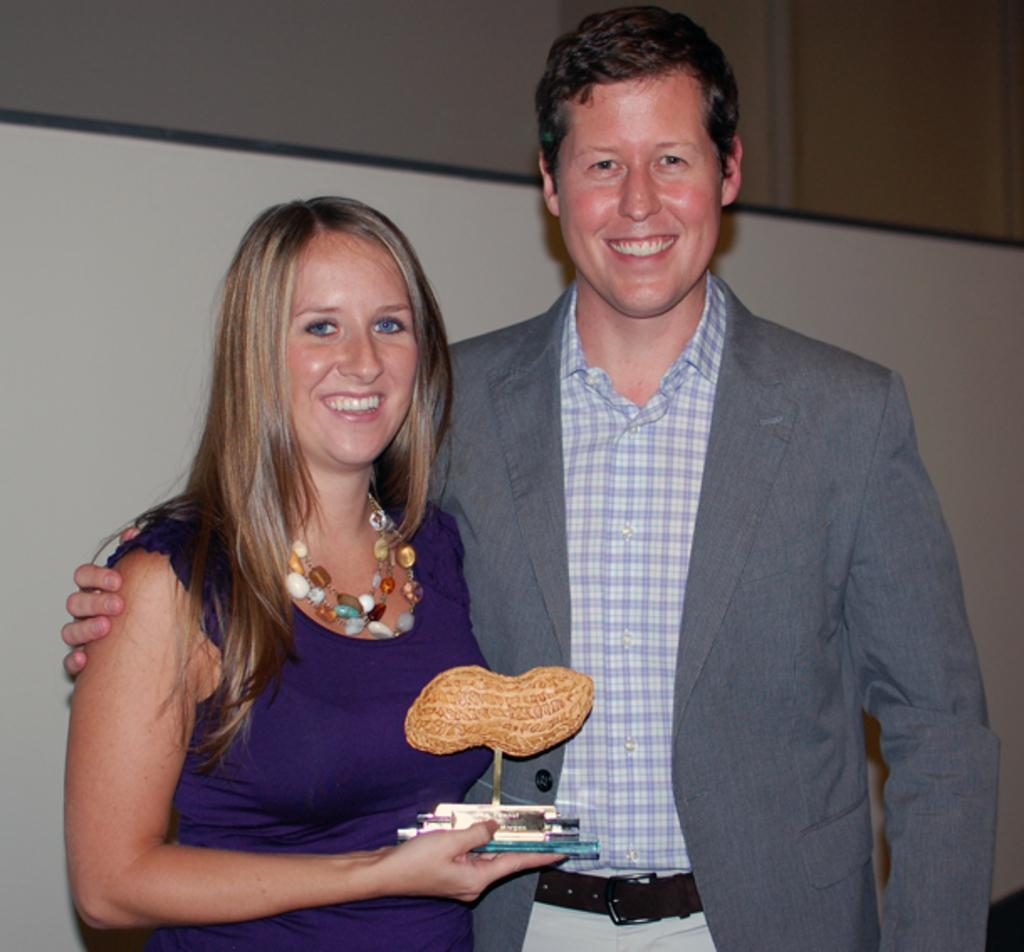Who are the people in the center of the image? There is a man and a woman in the center of the image. What is the woman holding in the image? The woman is holding something, but the specific object cannot be determined from the facts provided. What is the facial expression of the man and woman? Both the man and the woman are smiling. What can be seen in the background of the image? There is a wall and a screen in the background of the image. What type of snow can be seen falling in the image? There is no snow present in the image. How many cows are visible in the image? There are no cows present in the image. 